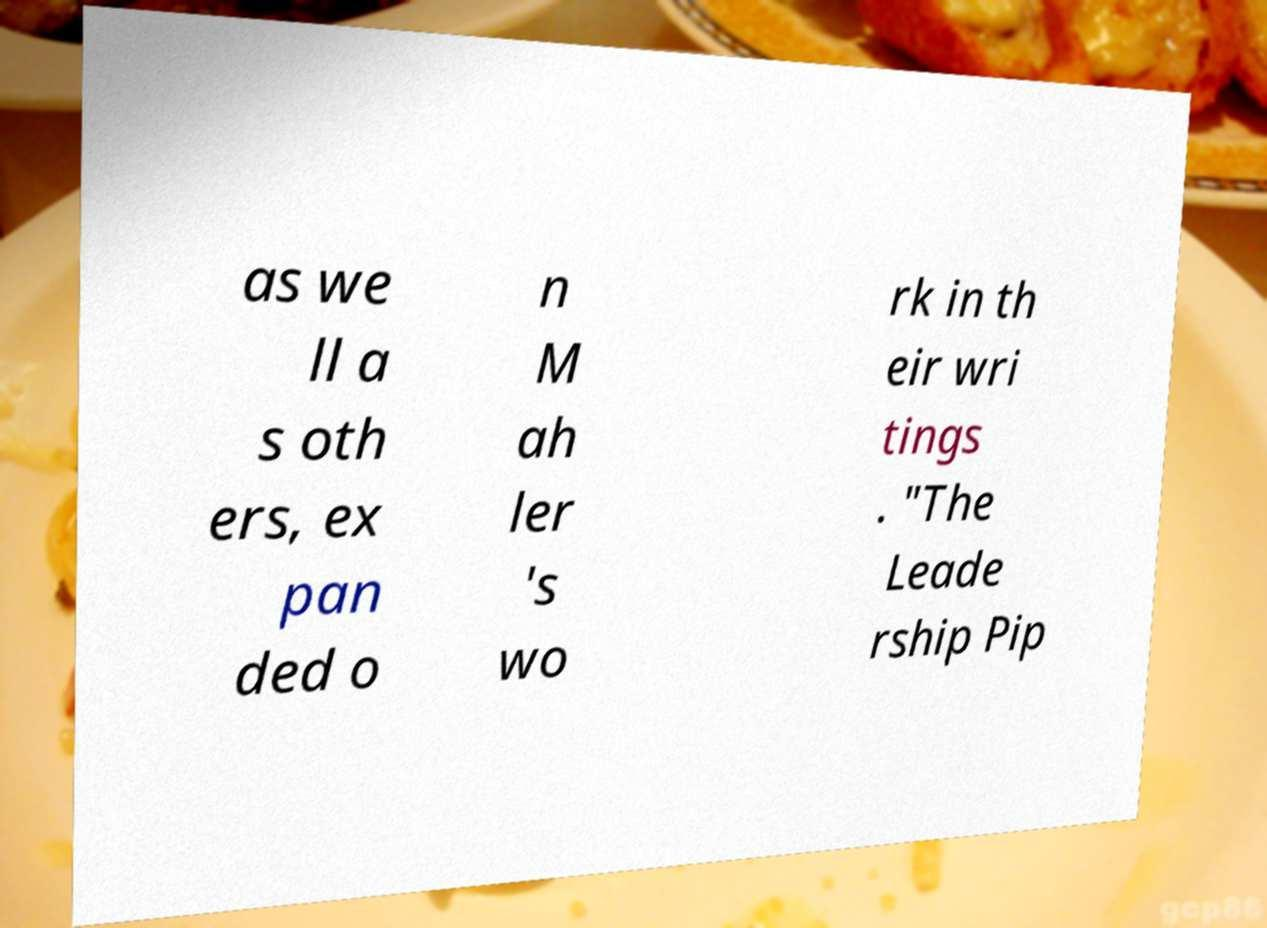Can you accurately transcribe the text from the provided image for me? as we ll a s oth ers, ex pan ded o n M ah ler 's wo rk in th eir wri tings . "The Leade rship Pip 